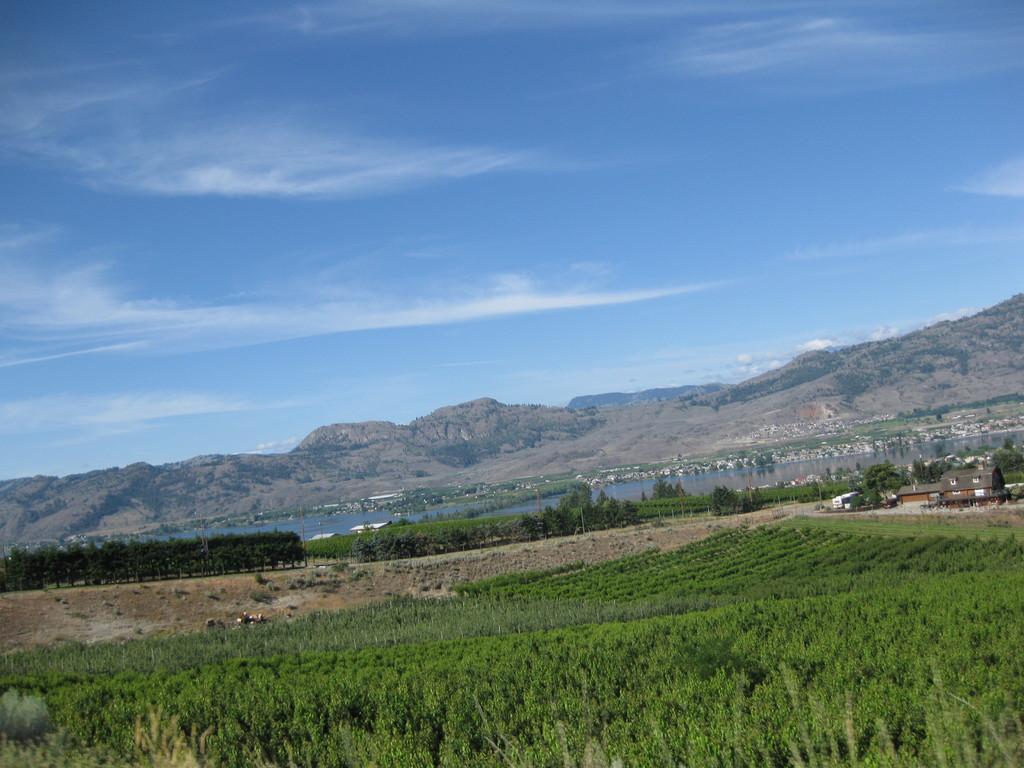Please provide a concise description of this image. In this picture we can see the plants, trees and houses. Behind the houses there is a lake, hills and the sky. 